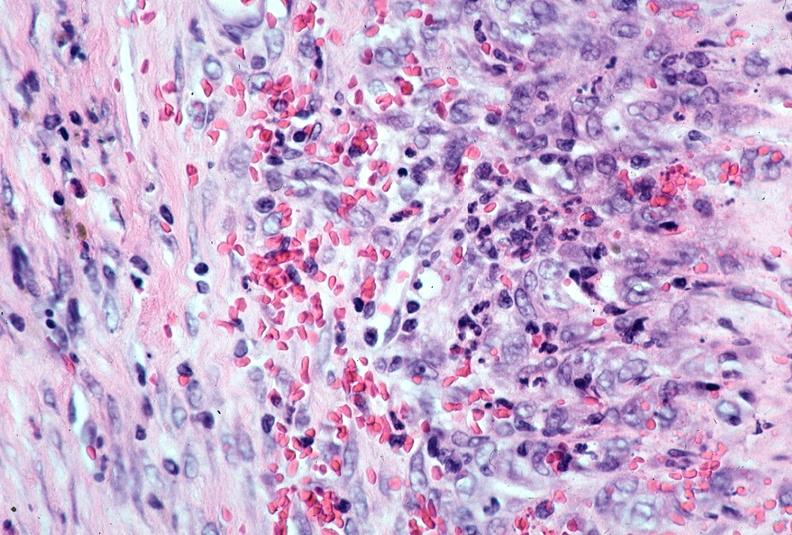where is this from?
Answer the question using a single word or phrase. Vasculature 